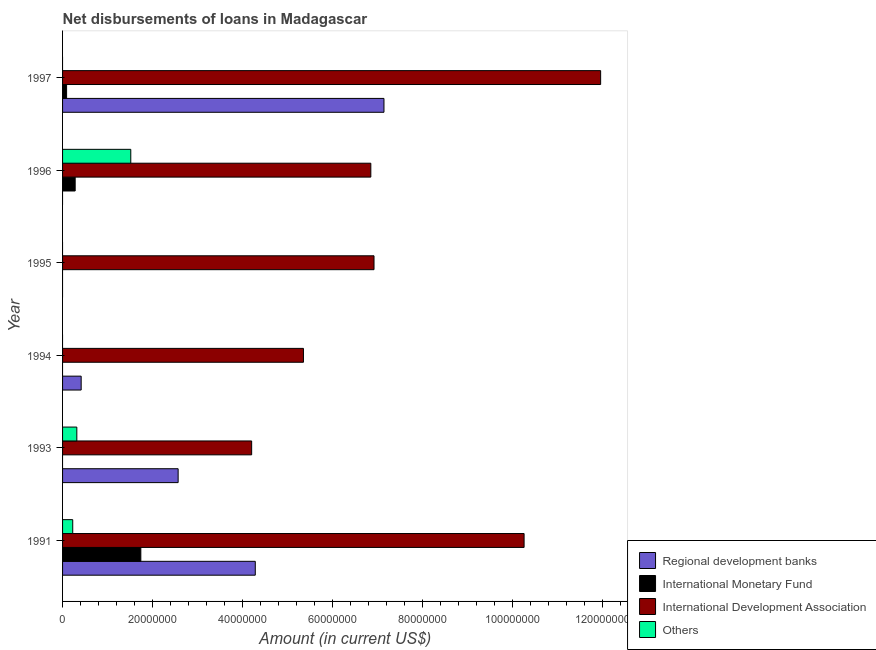How many different coloured bars are there?
Your answer should be compact. 4. Are the number of bars on each tick of the Y-axis equal?
Make the answer very short. No. How many bars are there on the 3rd tick from the top?
Ensure brevity in your answer.  1. How many bars are there on the 5th tick from the bottom?
Keep it short and to the point. 3. What is the label of the 5th group of bars from the top?
Provide a succinct answer. 1993. In how many cases, is the number of bars for a given year not equal to the number of legend labels?
Provide a short and direct response. 5. What is the amount of loan disimbursed by international development association in 1997?
Provide a succinct answer. 1.20e+08. Across all years, what is the maximum amount of loan disimbursed by international development association?
Offer a terse response. 1.20e+08. In which year was the amount of loan disimbursed by regional development banks maximum?
Give a very brief answer. 1997. What is the total amount of loan disimbursed by other organisations in the graph?
Give a very brief answer. 2.06e+07. What is the difference between the amount of loan disimbursed by international monetary fund in 1991 and that in 1996?
Offer a very short reply. 1.46e+07. What is the difference between the amount of loan disimbursed by international monetary fund in 1997 and the amount of loan disimbursed by other organisations in 1993?
Give a very brief answer. -2.28e+06. What is the average amount of loan disimbursed by regional development banks per year?
Provide a succinct answer. 2.40e+07. In the year 1993, what is the difference between the amount of loan disimbursed by regional development banks and amount of loan disimbursed by other organisations?
Provide a short and direct response. 2.25e+07. In how many years, is the amount of loan disimbursed by regional development banks greater than 80000000 US$?
Your answer should be very brief. 0. What is the ratio of the amount of loan disimbursed by international development association in 1993 to that in 1994?
Ensure brevity in your answer.  0.79. What is the difference between the highest and the second highest amount of loan disimbursed by international development association?
Offer a very short reply. 1.70e+07. What is the difference between the highest and the lowest amount of loan disimbursed by international monetary fund?
Ensure brevity in your answer.  1.74e+07. Is the sum of the amount of loan disimbursed by international development association in 1996 and 1997 greater than the maximum amount of loan disimbursed by regional development banks across all years?
Your response must be concise. Yes. How many bars are there?
Provide a succinct answer. 16. Are all the bars in the graph horizontal?
Provide a short and direct response. Yes. What is the difference between two consecutive major ticks on the X-axis?
Give a very brief answer. 2.00e+07. Does the graph contain any zero values?
Provide a succinct answer. Yes. What is the title of the graph?
Ensure brevity in your answer.  Net disbursements of loans in Madagascar. What is the label or title of the X-axis?
Offer a very short reply. Amount (in current US$). What is the label or title of the Y-axis?
Your response must be concise. Year. What is the Amount (in current US$) in Regional development banks in 1991?
Your response must be concise. 4.29e+07. What is the Amount (in current US$) of International Monetary Fund in 1991?
Offer a terse response. 1.74e+07. What is the Amount (in current US$) in International Development Association in 1991?
Make the answer very short. 1.03e+08. What is the Amount (in current US$) in Others in 1991?
Your response must be concise. 2.26e+06. What is the Amount (in current US$) of Regional development banks in 1993?
Offer a terse response. 2.57e+07. What is the Amount (in current US$) of International Monetary Fund in 1993?
Make the answer very short. 0. What is the Amount (in current US$) of International Development Association in 1993?
Provide a short and direct response. 4.21e+07. What is the Amount (in current US$) of Others in 1993?
Give a very brief answer. 3.17e+06. What is the Amount (in current US$) of Regional development banks in 1994?
Provide a short and direct response. 4.14e+06. What is the Amount (in current US$) of International Monetary Fund in 1994?
Provide a succinct answer. 0. What is the Amount (in current US$) of International Development Association in 1994?
Ensure brevity in your answer.  5.36e+07. What is the Amount (in current US$) of Regional development banks in 1995?
Offer a very short reply. 0. What is the Amount (in current US$) in International Development Association in 1995?
Your answer should be compact. 6.93e+07. What is the Amount (in current US$) of International Monetary Fund in 1996?
Offer a terse response. 2.80e+06. What is the Amount (in current US$) of International Development Association in 1996?
Ensure brevity in your answer.  6.86e+07. What is the Amount (in current US$) in Others in 1996?
Your answer should be very brief. 1.52e+07. What is the Amount (in current US$) of Regional development banks in 1997?
Your response must be concise. 7.15e+07. What is the Amount (in current US$) of International Monetary Fund in 1997?
Offer a very short reply. 8.96e+05. What is the Amount (in current US$) of International Development Association in 1997?
Offer a terse response. 1.20e+08. What is the Amount (in current US$) in Others in 1997?
Give a very brief answer. 0. Across all years, what is the maximum Amount (in current US$) of Regional development banks?
Offer a terse response. 7.15e+07. Across all years, what is the maximum Amount (in current US$) of International Monetary Fund?
Ensure brevity in your answer.  1.74e+07. Across all years, what is the maximum Amount (in current US$) of International Development Association?
Make the answer very short. 1.20e+08. Across all years, what is the maximum Amount (in current US$) in Others?
Your response must be concise. 1.52e+07. Across all years, what is the minimum Amount (in current US$) of Regional development banks?
Your response must be concise. 0. Across all years, what is the minimum Amount (in current US$) of International Monetary Fund?
Provide a succinct answer. 0. Across all years, what is the minimum Amount (in current US$) of International Development Association?
Give a very brief answer. 4.21e+07. What is the total Amount (in current US$) of Regional development banks in the graph?
Give a very brief answer. 1.44e+08. What is the total Amount (in current US$) of International Monetary Fund in the graph?
Offer a very short reply. 2.11e+07. What is the total Amount (in current US$) in International Development Association in the graph?
Keep it short and to the point. 4.56e+08. What is the total Amount (in current US$) of Others in the graph?
Provide a succinct answer. 2.06e+07. What is the difference between the Amount (in current US$) in Regional development banks in 1991 and that in 1993?
Your response must be concise. 1.72e+07. What is the difference between the Amount (in current US$) in International Development Association in 1991 and that in 1993?
Make the answer very short. 6.06e+07. What is the difference between the Amount (in current US$) of Others in 1991 and that in 1993?
Make the answer very short. -9.11e+05. What is the difference between the Amount (in current US$) in Regional development banks in 1991 and that in 1994?
Your answer should be compact. 3.87e+07. What is the difference between the Amount (in current US$) in International Development Association in 1991 and that in 1994?
Make the answer very short. 4.91e+07. What is the difference between the Amount (in current US$) in International Development Association in 1991 and that in 1995?
Keep it short and to the point. 3.34e+07. What is the difference between the Amount (in current US$) of International Monetary Fund in 1991 and that in 1996?
Provide a succinct answer. 1.46e+07. What is the difference between the Amount (in current US$) in International Development Association in 1991 and that in 1996?
Your response must be concise. 3.41e+07. What is the difference between the Amount (in current US$) of Others in 1991 and that in 1996?
Ensure brevity in your answer.  -1.29e+07. What is the difference between the Amount (in current US$) in Regional development banks in 1991 and that in 1997?
Offer a terse response. -2.86e+07. What is the difference between the Amount (in current US$) of International Monetary Fund in 1991 and that in 1997?
Offer a very short reply. 1.65e+07. What is the difference between the Amount (in current US$) of International Development Association in 1991 and that in 1997?
Your response must be concise. -1.70e+07. What is the difference between the Amount (in current US$) of Regional development banks in 1993 and that in 1994?
Ensure brevity in your answer.  2.16e+07. What is the difference between the Amount (in current US$) of International Development Association in 1993 and that in 1994?
Provide a short and direct response. -1.15e+07. What is the difference between the Amount (in current US$) in International Development Association in 1993 and that in 1995?
Your answer should be compact. -2.72e+07. What is the difference between the Amount (in current US$) of International Development Association in 1993 and that in 1996?
Make the answer very short. -2.65e+07. What is the difference between the Amount (in current US$) in Others in 1993 and that in 1996?
Make the answer very short. -1.20e+07. What is the difference between the Amount (in current US$) of Regional development banks in 1993 and that in 1997?
Offer a very short reply. -4.58e+07. What is the difference between the Amount (in current US$) of International Development Association in 1993 and that in 1997?
Offer a very short reply. -7.76e+07. What is the difference between the Amount (in current US$) in International Development Association in 1994 and that in 1995?
Your answer should be compact. -1.57e+07. What is the difference between the Amount (in current US$) in International Development Association in 1994 and that in 1996?
Provide a succinct answer. -1.50e+07. What is the difference between the Amount (in current US$) in Regional development banks in 1994 and that in 1997?
Provide a short and direct response. -6.73e+07. What is the difference between the Amount (in current US$) of International Development Association in 1994 and that in 1997?
Provide a short and direct response. -6.61e+07. What is the difference between the Amount (in current US$) in International Development Association in 1995 and that in 1996?
Your response must be concise. 7.11e+05. What is the difference between the Amount (in current US$) of International Development Association in 1995 and that in 1997?
Make the answer very short. -5.04e+07. What is the difference between the Amount (in current US$) in International Monetary Fund in 1996 and that in 1997?
Make the answer very short. 1.91e+06. What is the difference between the Amount (in current US$) of International Development Association in 1996 and that in 1997?
Ensure brevity in your answer.  -5.11e+07. What is the difference between the Amount (in current US$) in Regional development banks in 1991 and the Amount (in current US$) in International Development Association in 1993?
Make the answer very short. 8.03e+05. What is the difference between the Amount (in current US$) in Regional development banks in 1991 and the Amount (in current US$) in Others in 1993?
Give a very brief answer. 3.97e+07. What is the difference between the Amount (in current US$) in International Monetary Fund in 1991 and the Amount (in current US$) in International Development Association in 1993?
Offer a terse response. -2.47e+07. What is the difference between the Amount (in current US$) in International Monetary Fund in 1991 and the Amount (in current US$) in Others in 1993?
Make the answer very short. 1.42e+07. What is the difference between the Amount (in current US$) of International Development Association in 1991 and the Amount (in current US$) of Others in 1993?
Your response must be concise. 9.95e+07. What is the difference between the Amount (in current US$) of Regional development banks in 1991 and the Amount (in current US$) of International Development Association in 1994?
Make the answer very short. -1.07e+07. What is the difference between the Amount (in current US$) of International Monetary Fund in 1991 and the Amount (in current US$) of International Development Association in 1994?
Offer a very short reply. -3.62e+07. What is the difference between the Amount (in current US$) of Regional development banks in 1991 and the Amount (in current US$) of International Development Association in 1995?
Your answer should be compact. -2.64e+07. What is the difference between the Amount (in current US$) of International Monetary Fund in 1991 and the Amount (in current US$) of International Development Association in 1995?
Keep it short and to the point. -5.19e+07. What is the difference between the Amount (in current US$) in Regional development banks in 1991 and the Amount (in current US$) in International Monetary Fund in 1996?
Give a very brief answer. 4.01e+07. What is the difference between the Amount (in current US$) of Regional development banks in 1991 and the Amount (in current US$) of International Development Association in 1996?
Keep it short and to the point. -2.57e+07. What is the difference between the Amount (in current US$) in Regional development banks in 1991 and the Amount (in current US$) in Others in 1996?
Make the answer very short. 2.77e+07. What is the difference between the Amount (in current US$) of International Monetary Fund in 1991 and the Amount (in current US$) of International Development Association in 1996?
Make the answer very short. -5.12e+07. What is the difference between the Amount (in current US$) in International Monetary Fund in 1991 and the Amount (in current US$) in Others in 1996?
Provide a short and direct response. 2.24e+06. What is the difference between the Amount (in current US$) of International Development Association in 1991 and the Amount (in current US$) of Others in 1996?
Keep it short and to the point. 8.75e+07. What is the difference between the Amount (in current US$) of Regional development banks in 1991 and the Amount (in current US$) of International Monetary Fund in 1997?
Ensure brevity in your answer.  4.20e+07. What is the difference between the Amount (in current US$) of Regional development banks in 1991 and the Amount (in current US$) of International Development Association in 1997?
Ensure brevity in your answer.  -7.68e+07. What is the difference between the Amount (in current US$) in International Monetary Fund in 1991 and the Amount (in current US$) in International Development Association in 1997?
Keep it short and to the point. -1.02e+08. What is the difference between the Amount (in current US$) of Regional development banks in 1993 and the Amount (in current US$) of International Development Association in 1994?
Keep it short and to the point. -2.79e+07. What is the difference between the Amount (in current US$) in Regional development banks in 1993 and the Amount (in current US$) in International Development Association in 1995?
Provide a succinct answer. -4.36e+07. What is the difference between the Amount (in current US$) in Regional development banks in 1993 and the Amount (in current US$) in International Monetary Fund in 1996?
Your response must be concise. 2.29e+07. What is the difference between the Amount (in current US$) in Regional development banks in 1993 and the Amount (in current US$) in International Development Association in 1996?
Your answer should be compact. -4.29e+07. What is the difference between the Amount (in current US$) in Regional development banks in 1993 and the Amount (in current US$) in Others in 1996?
Provide a succinct answer. 1.05e+07. What is the difference between the Amount (in current US$) in International Development Association in 1993 and the Amount (in current US$) in Others in 1996?
Make the answer very short. 2.69e+07. What is the difference between the Amount (in current US$) in Regional development banks in 1993 and the Amount (in current US$) in International Monetary Fund in 1997?
Your answer should be very brief. 2.48e+07. What is the difference between the Amount (in current US$) in Regional development banks in 1993 and the Amount (in current US$) in International Development Association in 1997?
Ensure brevity in your answer.  -9.40e+07. What is the difference between the Amount (in current US$) in Regional development banks in 1994 and the Amount (in current US$) in International Development Association in 1995?
Provide a succinct answer. -6.51e+07. What is the difference between the Amount (in current US$) of Regional development banks in 1994 and the Amount (in current US$) of International Monetary Fund in 1996?
Offer a terse response. 1.33e+06. What is the difference between the Amount (in current US$) of Regional development banks in 1994 and the Amount (in current US$) of International Development Association in 1996?
Provide a succinct answer. -6.44e+07. What is the difference between the Amount (in current US$) of Regional development banks in 1994 and the Amount (in current US$) of Others in 1996?
Your answer should be very brief. -1.10e+07. What is the difference between the Amount (in current US$) in International Development Association in 1994 and the Amount (in current US$) in Others in 1996?
Make the answer very short. 3.84e+07. What is the difference between the Amount (in current US$) in Regional development banks in 1994 and the Amount (in current US$) in International Monetary Fund in 1997?
Keep it short and to the point. 3.24e+06. What is the difference between the Amount (in current US$) in Regional development banks in 1994 and the Amount (in current US$) in International Development Association in 1997?
Your response must be concise. -1.16e+08. What is the difference between the Amount (in current US$) of International Development Association in 1995 and the Amount (in current US$) of Others in 1996?
Make the answer very short. 5.41e+07. What is the difference between the Amount (in current US$) in International Monetary Fund in 1996 and the Amount (in current US$) in International Development Association in 1997?
Provide a short and direct response. -1.17e+08. What is the average Amount (in current US$) in Regional development banks per year?
Your response must be concise. 2.40e+07. What is the average Amount (in current US$) in International Monetary Fund per year?
Keep it short and to the point. 3.52e+06. What is the average Amount (in current US$) in International Development Association per year?
Provide a short and direct response. 7.60e+07. What is the average Amount (in current US$) of Others per year?
Offer a terse response. 3.43e+06. In the year 1991, what is the difference between the Amount (in current US$) of Regional development banks and Amount (in current US$) of International Monetary Fund?
Make the answer very short. 2.55e+07. In the year 1991, what is the difference between the Amount (in current US$) in Regional development banks and Amount (in current US$) in International Development Association?
Ensure brevity in your answer.  -5.98e+07. In the year 1991, what is the difference between the Amount (in current US$) in Regional development banks and Amount (in current US$) in Others?
Give a very brief answer. 4.06e+07. In the year 1991, what is the difference between the Amount (in current US$) in International Monetary Fund and Amount (in current US$) in International Development Association?
Provide a succinct answer. -8.52e+07. In the year 1991, what is the difference between the Amount (in current US$) in International Monetary Fund and Amount (in current US$) in Others?
Provide a short and direct response. 1.51e+07. In the year 1991, what is the difference between the Amount (in current US$) in International Development Association and Amount (in current US$) in Others?
Your answer should be compact. 1.00e+08. In the year 1993, what is the difference between the Amount (in current US$) of Regional development banks and Amount (in current US$) of International Development Association?
Make the answer very short. -1.64e+07. In the year 1993, what is the difference between the Amount (in current US$) of Regional development banks and Amount (in current US$) of Others?
Ensure brevity in your answer.  2.25e+07. In the year 1993, what is the difference between the Amount (in current US$) in International Development Association and Amount (in current US$) in Others?
Make the answer very short. 3.89e+07. In the year 1994, what is the difference between the Amount (in current US$) in Regional development banks and Amount (in current US$) in International Development Association?
Provide a short and direct response. -4.94e+07. In the year 1996, what is the difference between the Amount (in current US$) of International Monetary Fund and Amount (in current US$) of International Development Association?
Give a very brief answer. -6.58e+07. In the year 1996, what is the difference between the Amount (in current US$) of International Monetary Fund and Amount (in current US$) of Others?
Keep it short and to the point. -1.24e+07. In the year 1996, what is the difference between the Amount (in current US$) in International Development Association and Amount (in current US$) in Others?
Your answer should be very brief. 5.34e+07. In the year 1997, what is the difference between the Amount (in current US$) in Regional development banks and Amount (in current US$) in International Monetary Fund?
Provide a succinct answer. 7.06e+07. In the year 1997, what is the difference between the Amount (in current US$) of Regional development banks and Amount (in current US$) of International Development Association?
Your answer should be very brief. -4.82e+07. In the year 1997, what is the difference between the Amount (in current US$) in International Monetary Fund and Amount (in current US$) in International Development Association?
Your response must be concise. -1.19e+08. What is the ratio of the Amount (in current US$) in Regional development banks in 1991 to that in 1993?
Offer a terse response. 1.67. What is the ratio of the Amount (in current US$) of International Development Association in 1991 to that in 1993?
Provide a short and direct response. 2.44. What is the ratio of the Amount (in current US$) of Others in 1991 to that in 1993?
Your response must be concise. 0.71. What is the ratio of the Amount (in current US$) of Regional development banks in 1991 to that in 1994?
Ensure brevity in your answer.  10.36. What is the ratio of the Amount (in current US$) in International Development Association in 1991 to that in 1994?
Your answer should be compact. 1.92. What is the ratio of the Amount (in current US$) in International Development Association in 1991 to that in 1995?
Your answer should be compact. 1.48. What is the ratio of the Amount (in current US$) in International Monetary Fund in 1991 to that in 1996?
Offer a very short reply. 6.21. What is the ratio of the Amount (in current US$) in International Development Association in 1991 to that in 1996?
Offer a very short reply. 1.5. What is the ratio of the Amount (in current US$) of Others in 1991 to that in 1996?
Provide a succinct answer. 0.15. What is the ratio of the Amount (in current US$) in Regional development banks in 1991 to that in 1997?
Provide a short and direct response. 0.6. What is the ratio of the Amount (in current US$) in International Monetary Fund in 1991 to that in 1997?
Keep it short and to the point. 19.43. What is the ratio of the Amount (in current US$) of International Development Association in 1991 to that in 1997?
Keep it short and to the point. 0.86. What is the ratio of the Amount (in current US$) in Regional development banks in 1993 to that in 1994?
Provide a short and direct response. 6.21. What is the ratio of the Amount (in current US$) in International Development Association in 1993 to that in 1994?
Your answer should be very brief. 0.79. What is the ratio of the Amount (in current US$) in International Development Association in 1993 to that in 1995?
Make the answer very short. 0.61. What is the ratio of the Amount (in current US$) of International Development Association in 1993 to that in 1996?
Provide a succinct answer. 0.61. What is the ratio of the Amount (in current US$) of Others in 1993 to that in 1996?
Ensure brevity in your answer.  0.21. What is the ratio of the Amount (in current US$) in Regional development banks in 1993 to that in 1997?
Give a very brief answer. 0.36. What is the ratio of the Amount (in current US$) of International Development Association in 1993 to that in 1997?
Offer a very short reply. 0.35. What is the ratio of the Amount (in current US$) of International Development Association in 1994 to that in 1995?
Your answer should be very brief. 0.77. What is the ratio of the Amount (in current US$) in International Development Association in 1994 to that in 1996?
Ensure brevity in your answer.  0.78. What is the ratio of the Amount (in current US$) in Regional development banks in 1994 to that in 1997?
Offer a very short reply. 0.06. What is the ratio of the Amount (in current US$) of International Development Association in 1994 to that in 1997?
Keep it short and to the point. 0.45. What is the ratio of the Amount (in current US$) in International Development Association in 1995 to that in 1996?
Keep it short and to the point. 1.01. What is the ratio of the Amount (in current US$) in International Development Association in 1995 to that in 1997?
Make the answer very short. 0.58. What is the ratio of the Amount (in current US$) in International Monetary Fund in 1996 to that in 1997?
Keep it short and to the point. 3.13. What is the ratio of the Amount (in current US$) of International Development Association in 1996 to that in 1997?
Keep it short and to the point. 0.57. What is the difference between the highest and the second highest Amount (in current US$) in Regional development banks?
Ensure brevity in your answer.  2.86e+07. What is the difference between the highest and the second highest Amount (in current US$) of International Monetary Fund?
Give a very brief answer. 1.46e+07. What is the difference between the highest and the second highest Amount (in current US$) in International Development Association?
Make the answer very short. 1.70e+07. What is the difference between the highest and the second highest Amount (in current US$) of Others?
Provide a short and direct response. 1.20e+07. What is the difference between the highest and the lowest Amount (in current US$) in Regional development banks?
Make the answer very short. 7.15e+07. What is the difference between the highest and the lowest Amount (in current US$) in International Monetary Fund?
Give a very brief answer. 1.74e+07. What is the difference between the highest and the lowest Amount (in current US$) of International Development Association?
Give a very brief answer. 7.76e+07. What is the difference between the highest and the lowest Amount (in current US$) of Others?
Ensure brevity in your answer.  1.52e+07. 